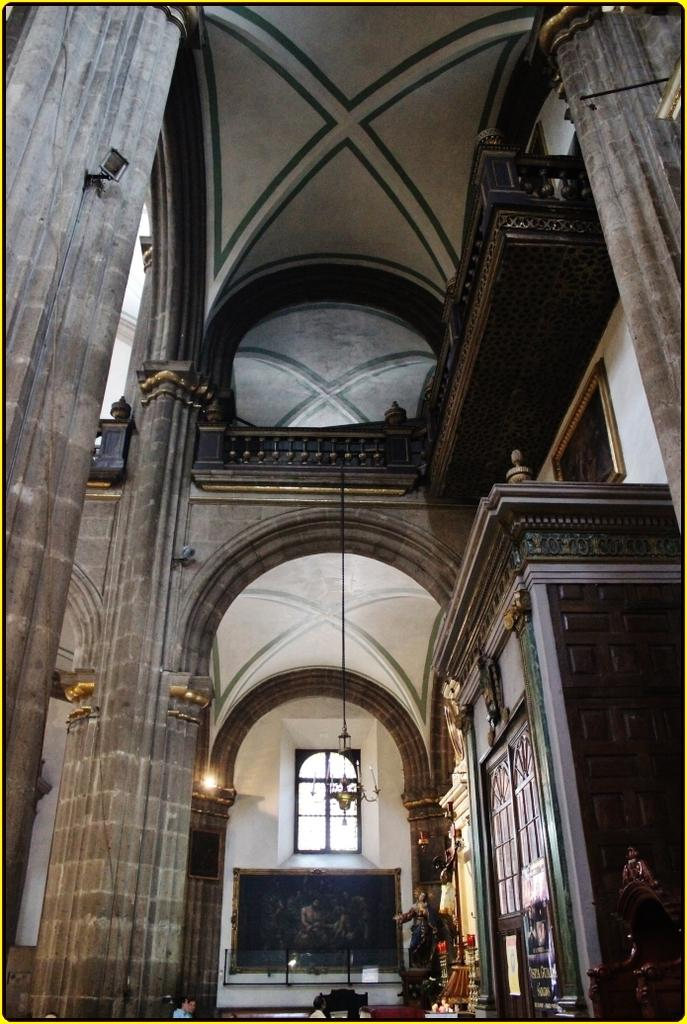Where was the image taken? The image was taken inside a building. What can be seen at the center of the image? There are statues at the center of the image. Can you describe any architectural features in the image? There is a wall frame and a pillar on the right side of the image. What type of lighting fixture is present in the image? There is a chandelier at the top of the image. What type of club is being used by the statue in the image? There is no club present in the image; the statues are stationary. Can you see a kite flying in the image? There is no kite present in the image. 